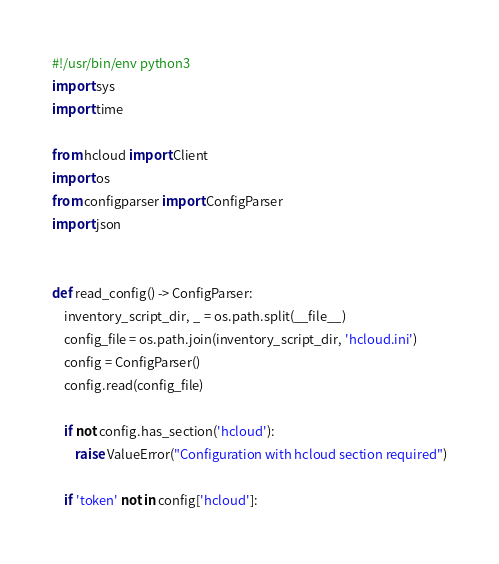<code> <loc_0><loc_0><loc_500><loc_500><_Python_>#!/usr/bin/env python3
import sys
import time

from hcloud import Client
import os
from configparser import ConfigParser
import json


def read_config() -> ConfigParser:
    inventory_script_dir, _ = os.path.split(__file__)
    config_file = os.path.join(inventory_script_dir, 'hcloud.ini')
    config = ConfigParser()
    config.read(config_file)

    if not config.has_section('hcloud'):
        raise ValueError("Configuration with hcloud section required")

    if 'token' not in config['hcloud']:</code> 